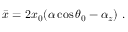Convert formula to latex. <formula><loc_0><loc_0><loc_500><loc_500>\bar { x } = 2 x _ { 0 } ( \alpha \cos \theta _ { 0 } - \alpha _ { z } ) \ .</formula> 